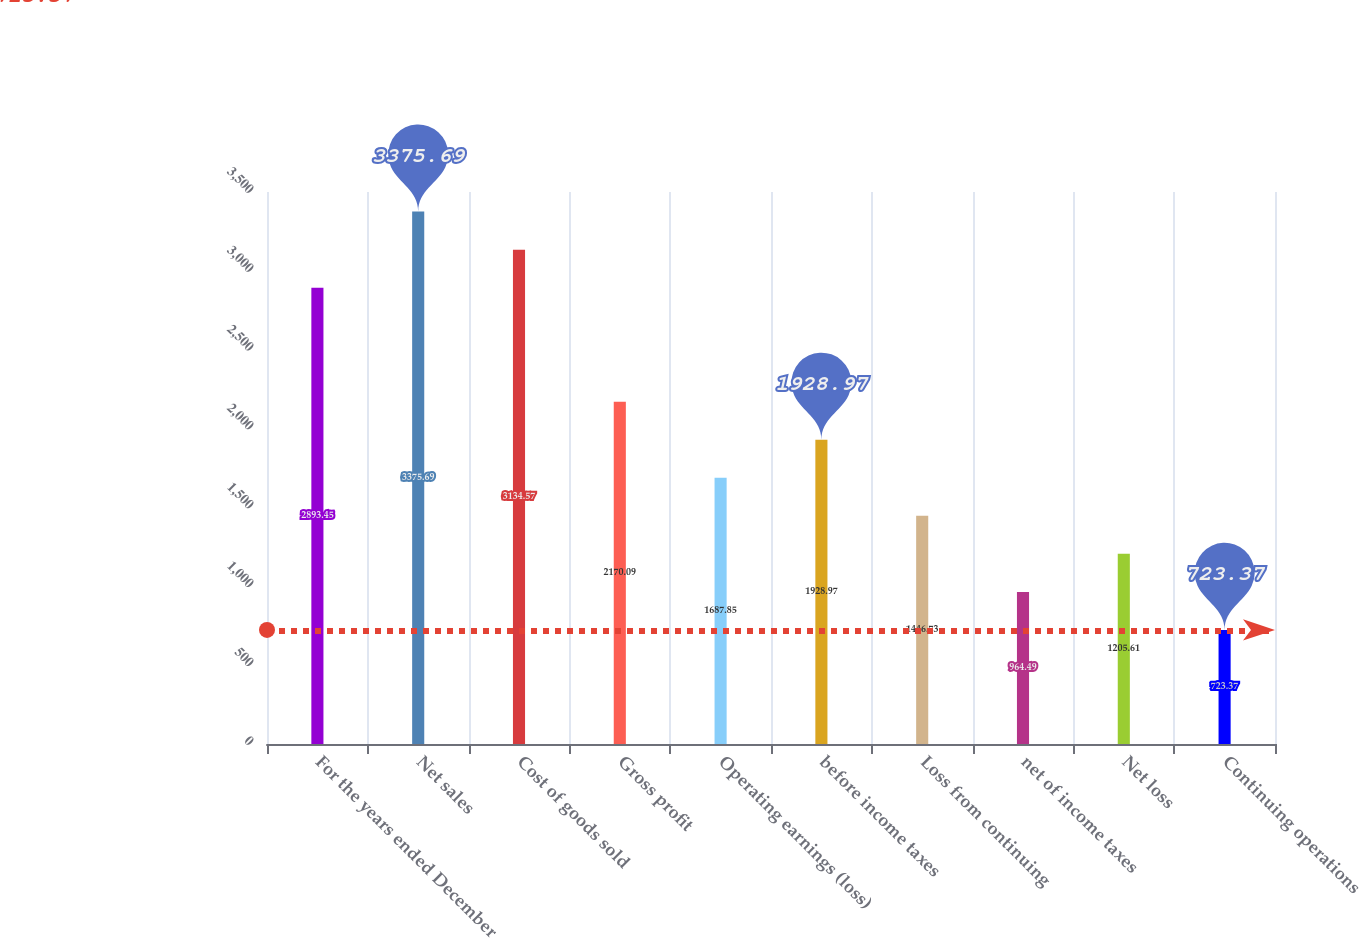Convert chart. <chart><loc_0><loc_0><loc_500><loc_500><bar_chart><fcel>For the years ended December<fcel>Net sales<fcel>Cost of goods sold<fcel>Gross profit<fcel>Operating earnings (loss)<fcel>before income taxes<fcel>Loss from continuing<fcel>net of income taxes<fcel>Net loss<fcel>Continuing operations<nl><fcel>2893.45<fcel>3375.69<fcel>3134.57<fcel>2170.09<fcel>1687.85<fcel>1928.97<fcel>1446.73<fcel>964.49<fcel>1205.61<fcel>723.37<nl></chart> 